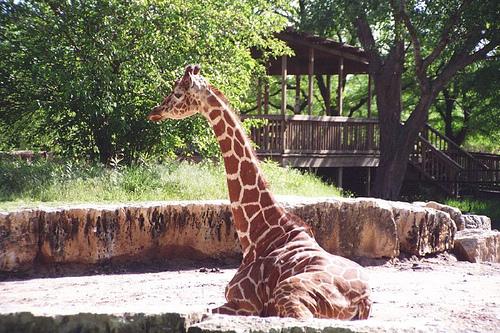Is the giraffe sleeping?
Keep it brief. No. Where is the giraffe?
Write a very short answer. Zoo. Is this a friendly animal?
Write a very short answer. Yes. 